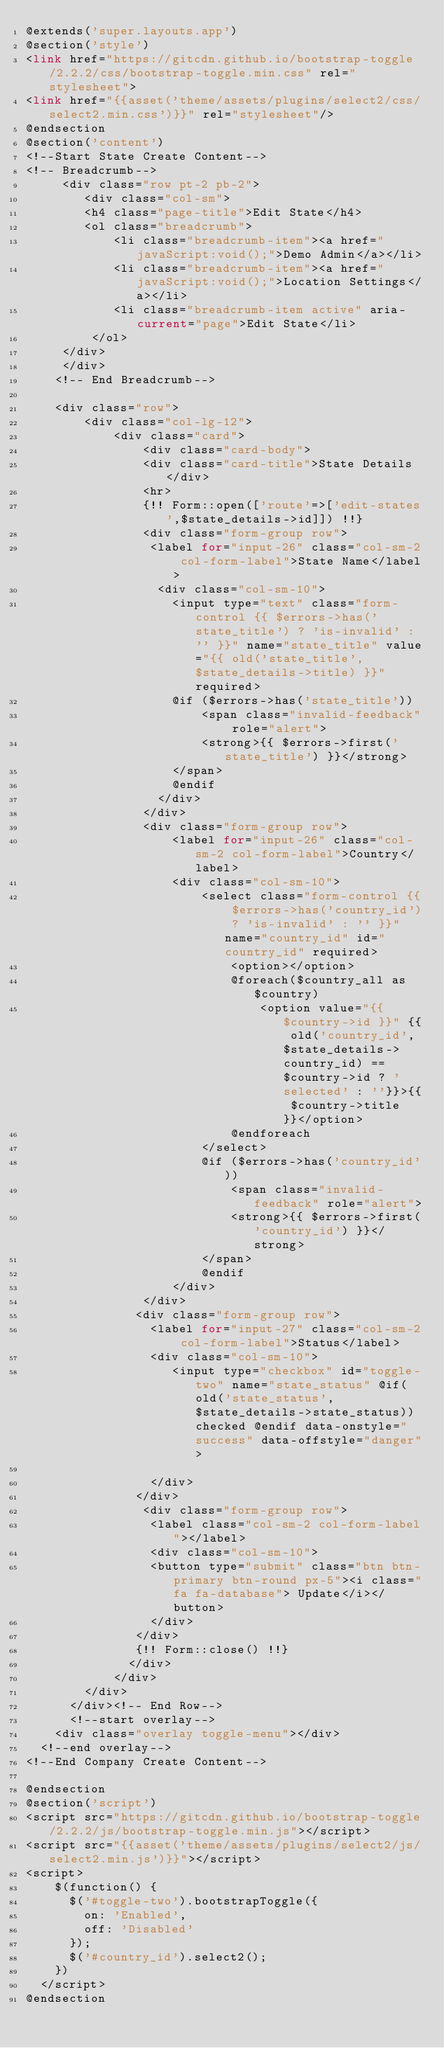Convert code to text. <code><loc_0><loc_0><loc_500><loc_500><_PHP_>@extends('super.layouts.app')
@section('style')
<link href="https://gitcdn.github.io/bootstrap-toggle/2.2.2/css/bootstrap-toggle.min.css" rel="stylesheet">
<link href="{{asset('theme/assets/plugins/select2/css/select2.min.css')}}" rel="stylesheet"/>
@endsection
@section('content')
<!--Start State Create Content-->
<!-- Breadcrumb-->
     <div class="row pt-2 pb-2">
        <div class="col-sm">
		    <h4 class="page-title">Edit State</h4>
		    <ol class="breadcrumb">
            <li class="breadcrumb-item"><a href="javaScript:void();">Demo Admin</a></li>
            <li class="breadcrumb-item"><a href="javaScript:void();">Location Settings</a></li>
            <li class="breadcrumb-item active" aria-current="page">Edit State</li>
         </ol>
	   </div>
     </div>
    <!-- End Breadcrumb-->
    
    <div class="row">
        <div class="col-lg-12">
            <div class="card">
                <div class="card-body">
                <div class="card-title">State Details</div>
                <hr>
                {!! Form::open(['route'=>['edit-states',$state_details->id]]) !!}
                <div class="form-group row">
                 <label for="input-26" class="col-sm-2 col-form-label">State Name</label>
                  <div class="col-sm-10">
                    <input type="text" class="form-control {{ $errors->has('state_title') ? 'is-invalid' : '' }}" name="state_title" value="{{ old('state_title', $state_details->title) }}" required>
                    @if ($errors->has('state_title'))
                        <span class="invalid-feedback" role="alert">
                        <strong>{{ $errors->first('state_title') }}</strong>
                    </span>
                    @endif
                  </div>
                </div>
                <div class="form-group row">
                    <label for="input-26" class="col-sm-2 col-form-label">Country</label>
                    <div class="col-sm-10">
                        <select class="form-control {{ $errors->has('country_id') ? 'is-invalid' : '' }}" name="country_id" id="country_id" required>
                            <option></option>
                            @foreach($country_all as $country)
                                <option value="{{ $country->id }}" {{ old('country_id', $state_details->country_id) == $country->id ? 'selected' : ''}}>{{ $country->title }}</option>
                            @endforeach
                        </select>
                        @if ($errors->has('country_id'))
                            <span class="invalid-feedback" role="alert">
                            <strong>{{ $errors->first('country_id') }}</strong>
                        </span>
                        @endif
                    </div>
                </div>
               <div class="form-group row">
                 <label for="input-27" class="col-sm-2 col-form-label">Status</label>
                 <div class="col-sm-10">
                    <input type="checkbox" id="toggle-two" name="state_status" @if(old('state_status',$state_details->state_status)) checked @endif data-onstyle="success" data-offstyle="danger">
                    
                 </div>
               </div>
                <div class="form-group row">
                 <label class="col-sm-2 col-form-label"></label>
                 <div class="col-sm-10">
                 <button type="submit" class="btn btn-primary btn-round px-5"><i class="fa fa-database"> Update</i></button>
                 </div>
               </div>
               {!! Form::close() !!}
              </div>
            </div>
        </div>
      </div><!-- End Row-->
      <!--start overlay-->
	  <div class="overlay toggle-menu"></div>
	<!--end overlay-->
<!--End Company Create Content-->

@endsection
@section('script')
<script src="https://gitcdn.github.io/bootstrap-toggle/2.2.2/js/bootstrap-toggle.min.js"></script>
<script src="{{asset('theme/assets/plugins/select2/js/select2.min.js')}}"></script>
<script>
    $(function() {
      $('#toggle-two').bootstrapToggle({
        on: 'Enabled',
        off: 'Disabled'
      });
      $('#country_id').select2();
    })
  </script>
@endsection
</code> 